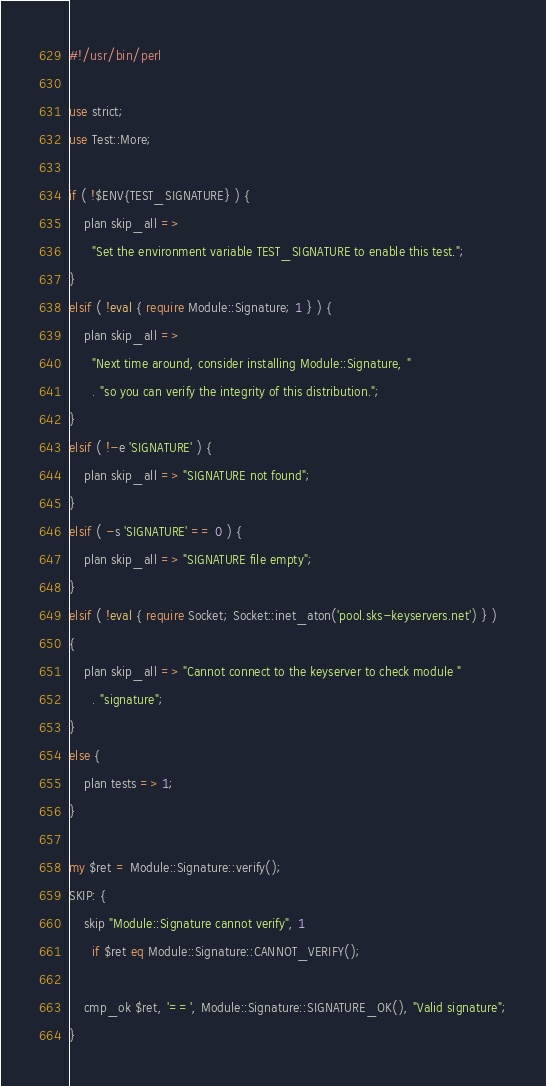Convert code to text. <code><loc_0><loc_0><loc_500><loc_500><_Perl_>#!/usr/bin/perl

use strict;
use Test::More;

if ( !$ENV{TEST_SIGNATURE} ) {
    plan skip_all =>
      "Set the environment variable TEST_SIGNATURE to enable this test.";
}
elsif ( !eval { require Module::Signature; 1 } ) {
    plan skip_all =>
      "Next time around, consider installing Module::Signature, "
      . "so you can verify the integrity of this distribution.";
}
elsif ( !-e 'SIGNATURE' ) {
    plan skip_all => "SIGNATURE not found";
}
elsif ( -s 'SIGNATURE' == 0 ) {
    plan skip_all => "SIGNATURE file empty";
}
elsif ( !eval { require Socket; Socket::inet_aton('pool.sks-keyservers.net') } )
{
    plan skip_all => "Cannot connect to the keyserver to check module "
      . "signature";
}
else {
    plan tests => 1;
}

my $ret = Module::Signature::verify();
SKIP: {
    skip "Module::Signature cannot verify", 1
      if $ret eq Module::Signature::CANNOT_VERIFY();

    cmp_ok $ret, '==', Module::Signature::SIGNATURE_OK(), "Valid signature";
}
</code> 